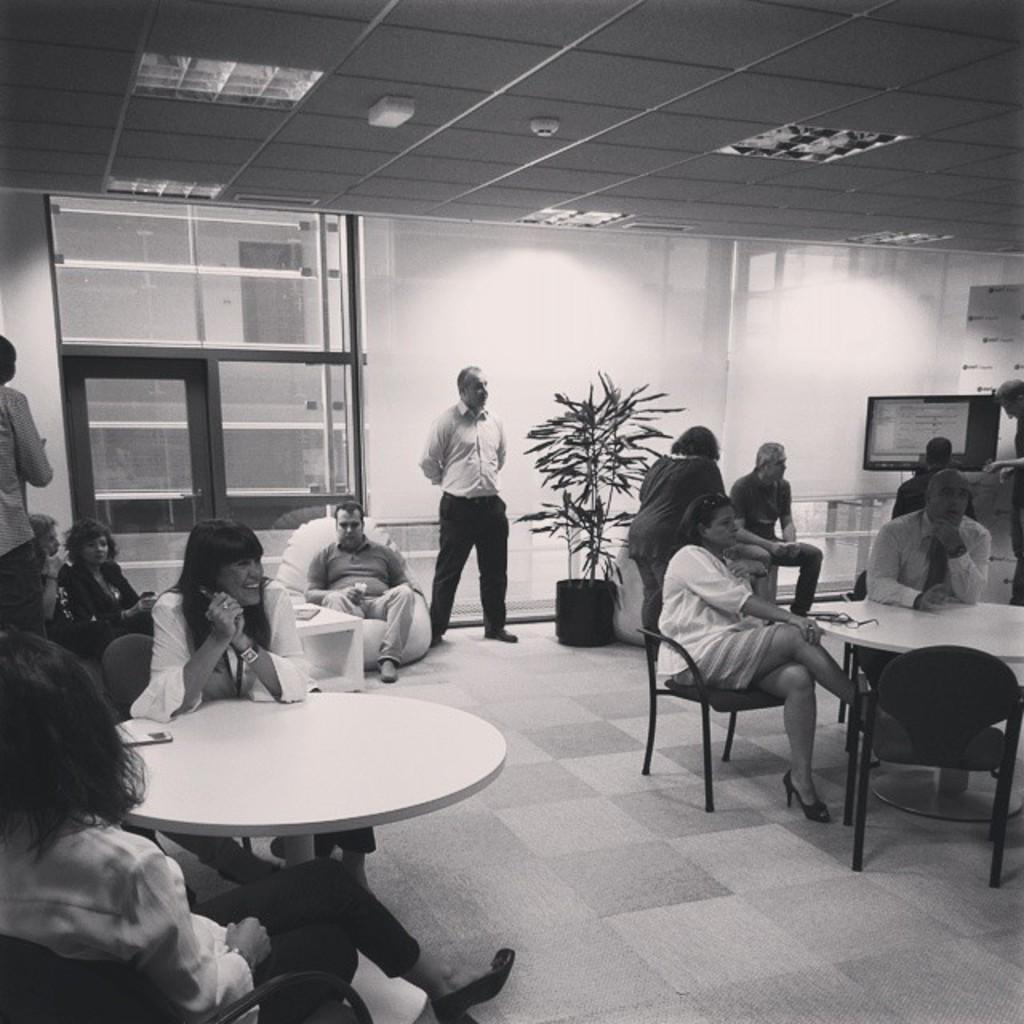What are the people in the image doing? There are people sitting on chairs and standing in the image. What can be seen in the background of the image? There is a wall, a plant, a television screen, and a window in the background of the image. What type of quilt is being used as a weapon by one of the people in the image? There is no quilt present in the image, nor is any weapon being used. Can you see a train in the background of the image? There is no train visible in the image; only a wall, a plant, a television screen, and a window can be seen in the background? 